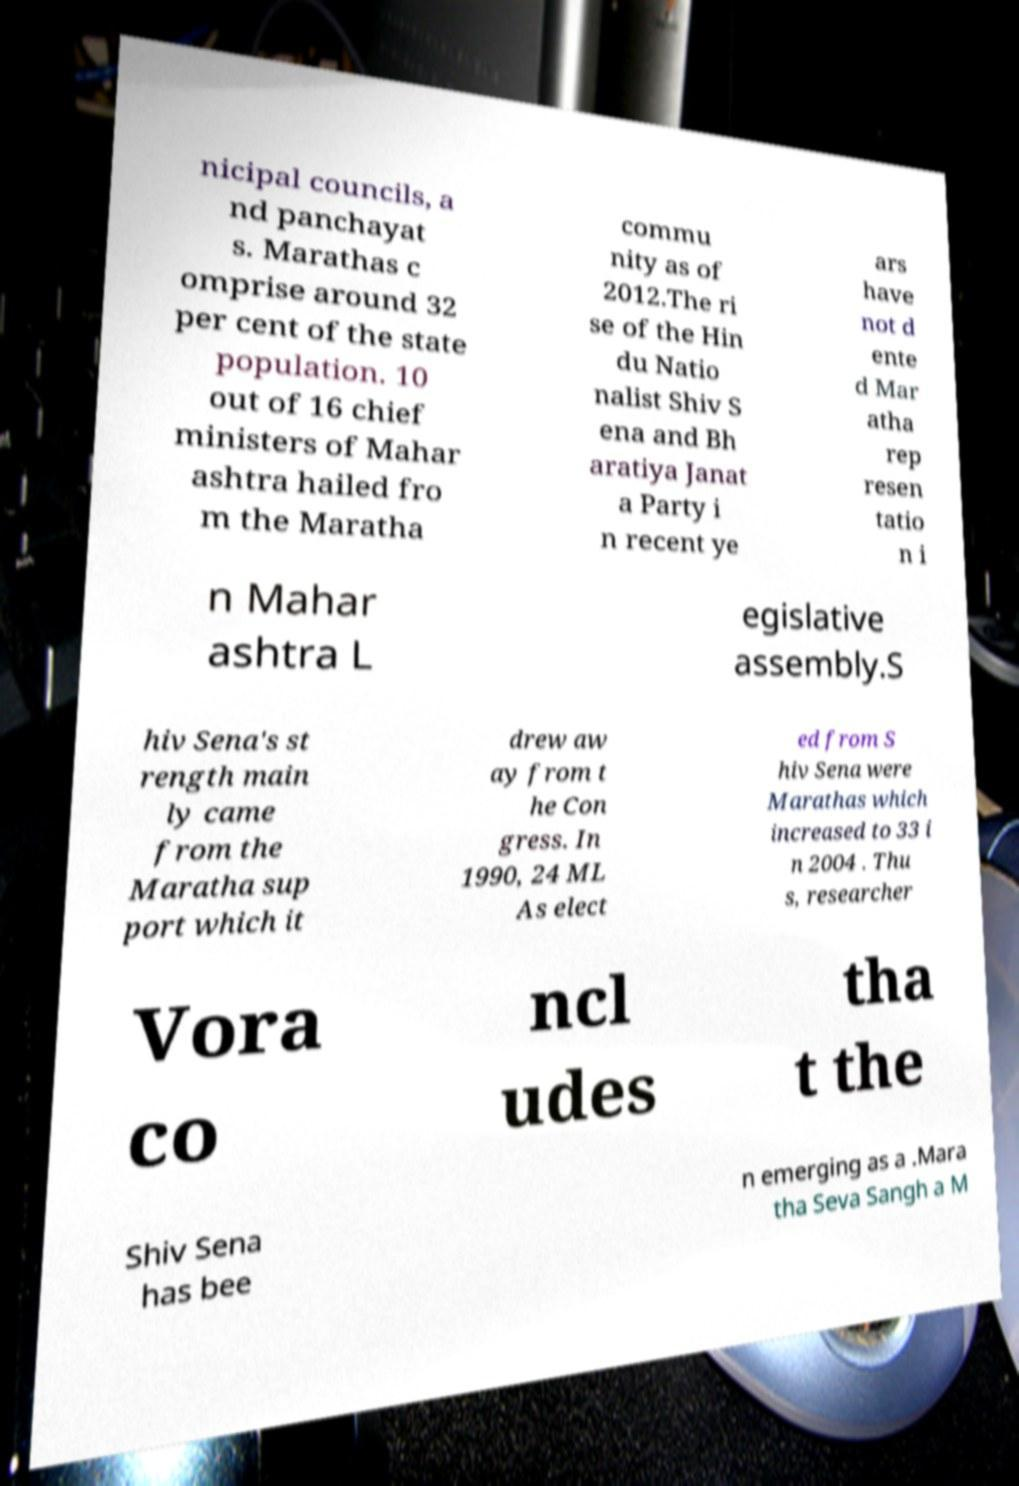I need the written content from this picture converted into text. Can you do that? nicipal councils, a nd panchayat s. Marathas c omprise around 32 per cent of the state population. 10 out of 16 chief ministers of Mahar ashtra hailed fro m the Maratha commu nity as of 2012.The ri se of the Hin du Natio nalist Shiv S ena and Bh aratiya Janat a Party i n recent ye ars have not d ente d Mar atha rep resen tatio n i n Mahar ashtra L egislative assembly.S hiv Sena's st rength main ly came from the Maratha sup port which it drew aw ay from t he Con gress. In 1990, 24 ML As elect ed from S hiv Sena were Marathas which increased to 33 i n 2004 . Thu s, researcher Vora co ncl udes tha t the Shiv Sena has bee n emerging as a .Mara tha Seva Sangh a M 